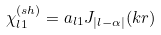<formula> <loc_0><loc_0><loc_500><loc_500>\chi _ { l 1 } ^ { ( s h ) } = a _ { l 1 } J _ { | l - \alpha | } ( k r )</formula> 